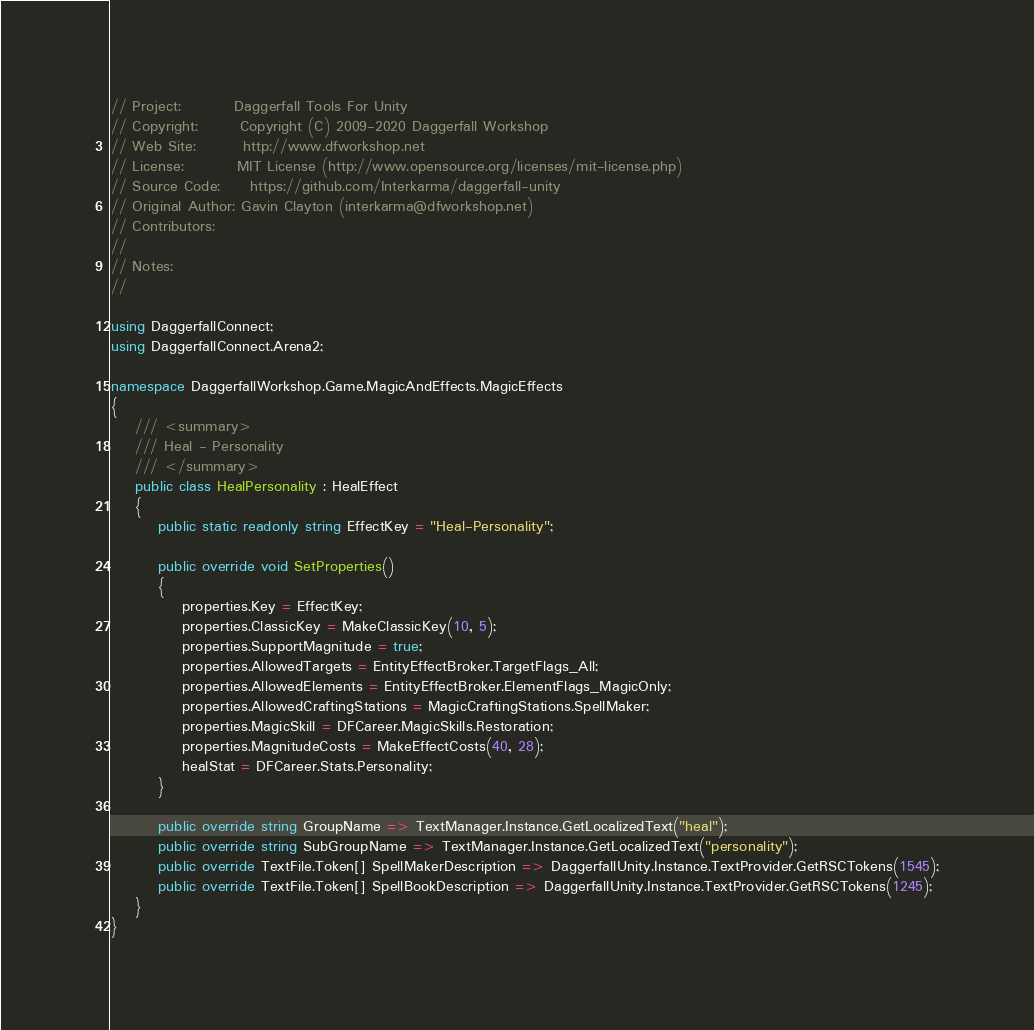Convert code to text. <code><loc_0><loc_0><loc_500><loc_500><_C#_>// Project:         Daggerfall Tools For Unity
// Copyright:       Copyright (C) 2009-2020 Daggerfall Workshop
// Web Site:        http://www.dfworkshop.net
// License:         MIT License (http://www.opensource.org/licenses/mit-license.php)
// Source Code:     https://github.com/Interkarma/daggerfall-unity
// Original Author: Gavin Clayton (interkarma@dfworkshop.net)
// Contributors:    
// 
// Notes:
//

using DaggerfallConnect;
using DaggerfallConnect.Arena2;

namespace DaggerfallWorkshop.Game.MagicAndEffects.MagicEffects
{
    /// <summary>
    /// Heal - Personality
    /// </summary>
    public class HealPersonality : HealEffect
    {
        public static readonly string EffectKey = "Heal-Personality";

        public override void SetProperties()
        {
            properties.Key = EffectKey;
            properties.ClassicKey = MakeClassicKey(10, 5);
            properties.SupportMagnitude = true;
            properties.AllowedTargets = EntityEffectBroker.TargetFlags_All;
            properties.AllowedElements = EntityEffectBroker.ElementFlags_MagicOnly;
            properties.AllowedCraftingStations = MagicCraftingStations.SpellMaker;
            properties.MagicSkill = DFCareer.MagicSkills.Restoration;
            properties.MagnitudeCosts = MakeEffectCosts(40, 28);
            healStat = DFCareer.Stats.Personality;
        }

        public override string GroupName => TextManager.Instance.GetLocalizedText("heal");
        public override string SubGroupName => TextManager.Instance.GetLocalizedText("personality");
        public override TextFile.Token[] SpellMakerDescription => DaggerfallUnity.Instance.TextProvider.GetRSCTokens(1545);
        public override TextFile.Token[] SpellBookDescription => DaggerfallUnity.Instance.TextProvider.GetRSCTokens(1245);
    }
}
</code> 